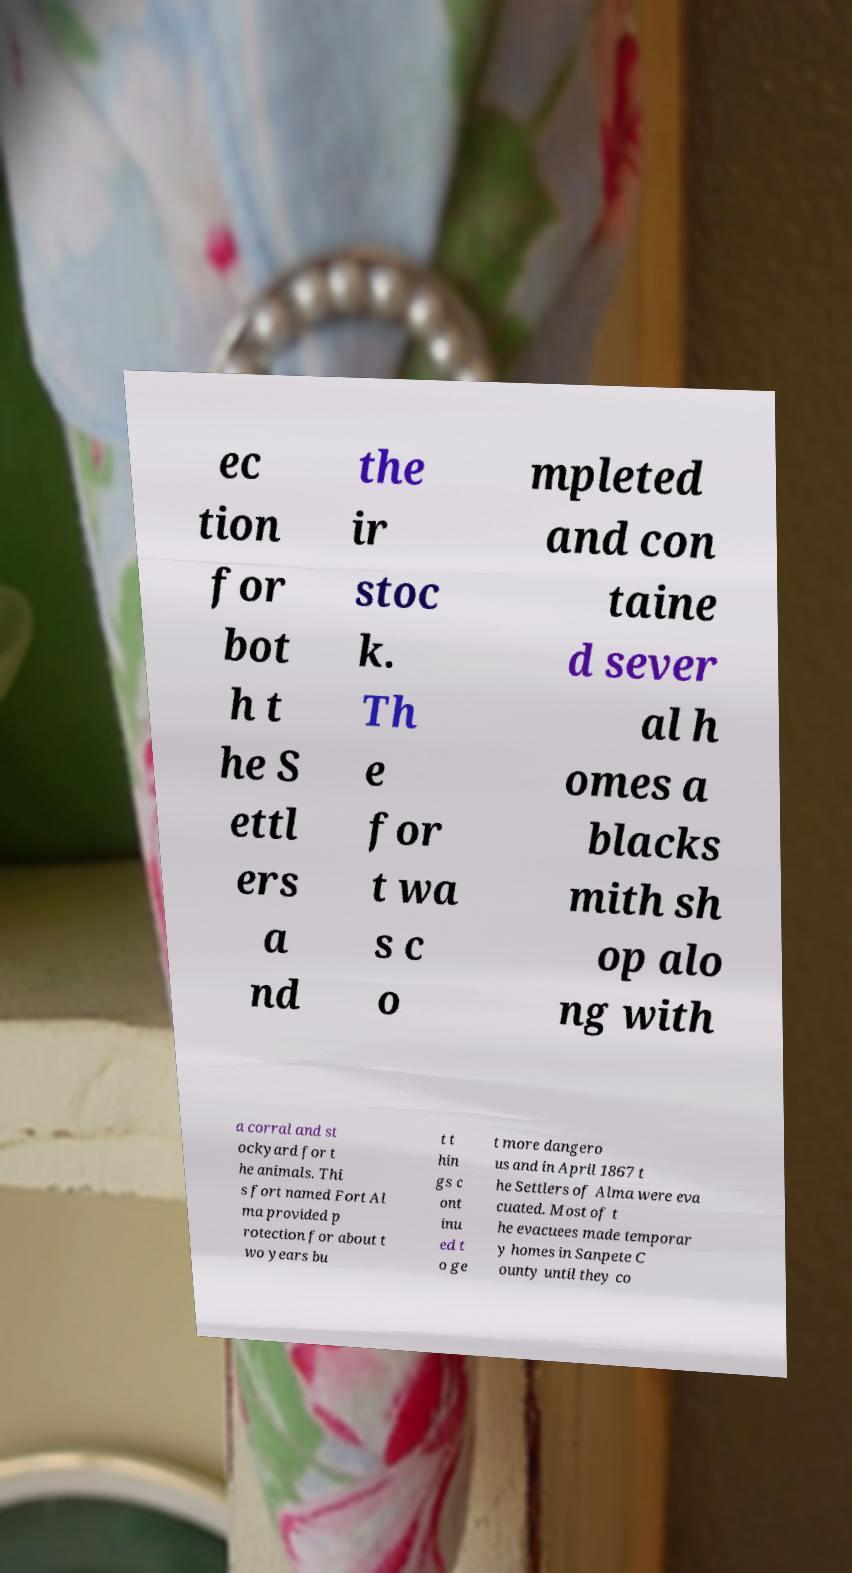What messages or text are displayed in this image? I need them in a readable, typed format. ec tion for bot h t he S ettl ers a nd the ir stoc k. Th e for t wa s c o mpleted and con taine d sever al h omes a blacks mith sh op alo ng with a corral and st ockyard for t he animals. Thi s fort named Fort Al ma provided p rotection for about t wo years bu t t hin gs c ont inu ed t o ge t more dangero us and in April 1867 t he Settlers of Alma were eva cuated. Most of t he evacuees made temporar y homes in Sanpete C ounty until they co 